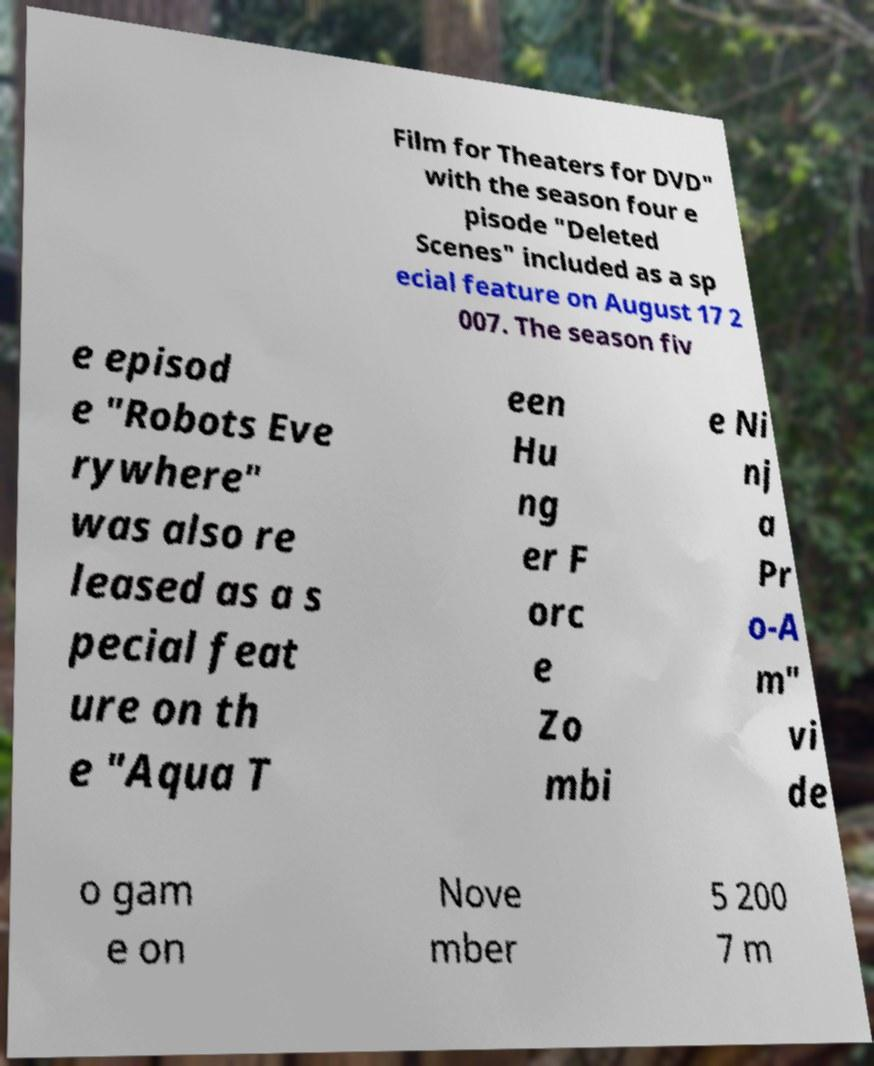There's text embedded in this image that I need extracted. Can you transcribe it verbatim? Film for Theaters for DVD" with the season four e pisode "Deleted Scenes" included as a sp ecial feature on August 17 2 007. The season fiv e episod e "Robots Eve rywhere" was also re leased as a s pecial feat ure on th e "Aqua T een Hu ng er F orc e Zo mbi e Ni nj a Pr o-A m" vi de o gam e on Nove mber 5 200 7 m 